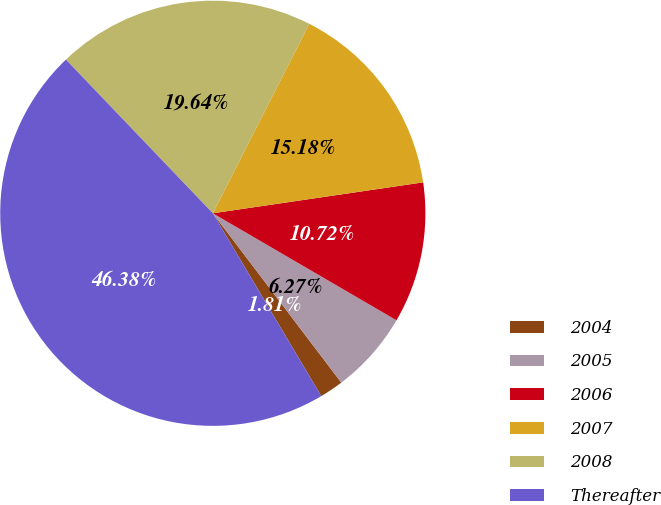<chart> <loc_0><loc_0><loc_500><loc_500><pie_chart><fcel>2004<fcel>2005<fcel>2006<fcel>2007<fcel>2008<fcel>Thereafter<nl><fcel>1.81%<fcel>6.27%<fcel>10.72%<fcel>15.18%<fcel>19.64%<fcel>46.38%<nl></chart> 